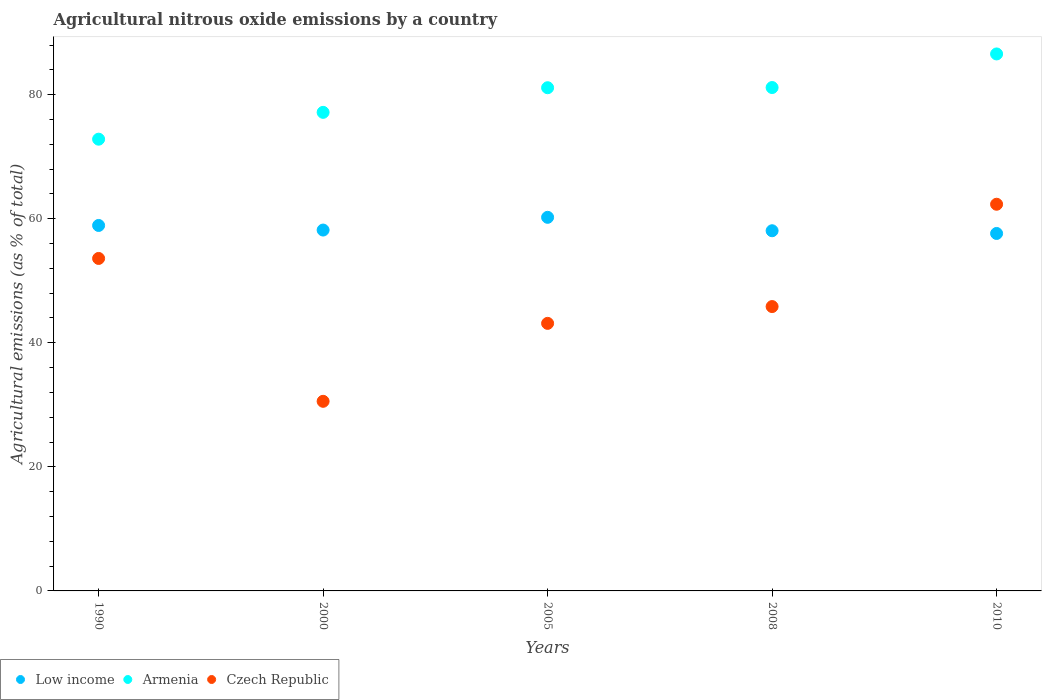Is the number of dotlines equal to the number of legend labels?
Provide a succinct answer. Yes. What is the amount of agricultural nitrous oxide emitted in Low income in 1990?
Provide a succinct answer. 58.91. Across all years, what is the maximum amount of agricultural nitrous oxide emitted in Armenia?
Offer a very short reply. 86.56. Across all years, what is the minimum amount of agricultural nitrous oxide emitted in Low income?
Offer a very short reply. 57.62. In which year was the amount of agricultural nitrous oxide emitted in Czech Republic maximum?
Offer a very short reply. 2010. What is the total amount of agricultural nitrous oxide emitted in Armenia in the graph?
Provide a succinct answer. 398.78. What is the difference between the amount of agricultural nitrous oxide emitted in Armenia in 2005 and that in 2010?
Keep it short and to the point. -5.45. What is the difference between the amount of agricultural nitrous oxide emitted in Armenia in 1990 and the amount of agricultural nitrous oxide emitted in Czech Republic in 2010?
Your answer should be very brief. 10.49. What is the average amount of agricultural nitrous oxide emitted in Armenia per year?
Offer a terse response. 79.76. In the year 1990, what is the difference between the amount of agricultural nitrous oxide emitted in Armenia and amount of agricultural nitrous oxide emitted in Low income?
Offer a terse response. 13.91. What is the ratio of the amount of agricultural nitrous oxide emitted in Low income in 2005 to that in 2010?
Provide a succinct answer. 1.05. Is the amount of agricultural nitrous oxide emitted in Armenia in 2000 less than that in 2005?
Keep it short and to the point. Yes. What is the difference between the highest and the second highest amount of agricultural nitrous oxide emitted in Armenia?
Give a very brief answer. 5.41. What is the difference between the highest and the lowest amount of agricultural nitrous oxide emitted in Czech Republic?
Ensure brevity in your answer.  31.77. Does the amount of agricultural nitrous oxide emitted in Armenia monotonically increase over the years?
Offer a terse response. Yes. Is the amount of agricultural nitrous oxide emitted in Armenia strictly greater than the amount of agricultural nitrous oxide emitted in Low income over the years?
Ensure brevity in your answer.  Yes. Is the amount of agricultural nitrous oxide emitted in Low income strictly less than the amount of agricultural nitrous oxide emitted in Armenia over the years?
Keep it short and to the point. Yes. Are the values on the major ticks of Y-axis written in scientific E-notation?
Make the answer very short. No. How many legend labels are there?
Provide a short and direct response. 3. What is the title of the graph?
Your answer should be very brief. Agricultural nitrous oxide emissions by a country. Does "West Bank and Gaza" appear as one of the legend labels in the graph?
Provide a succinct answer. No. What is the label or title of the Y-axis?
Ensure brevity in your answer.  Agricultural emissions (as % of total). What is the Agricultural emissions (as % of total) of Low income in 1990?
Your answer should be very brief. 58.91. What is the Agricultural emissions (as % of total) of Armenia in 1990?
Your answer should be compact. 72.82. What is the Agricultural emissions (as % of total) in Czech Republic in 1990?
Your answer should be compact. 53.6. What is the Agricultural emissions (as % of total) of Low income in 2000?
Provide a succinct answer. 58.17. What is the Agricultural emissions (as % of total) in Armenia in 2000?
Offer a terse response. 77.14. What is the Agricultural emissions (as % of total) in Czech Republic in 2000?
Give a very brief answer. 30.56. What is the Agricultural emissions (as % of total) of Low income in 2005?
Your answer should be compact. 60.22. What is the Agricultural emissions (as % of total) of Armenia in 2005?
Ensure brevity in your answer.  81.11. What is the Agricultural emissions (as % of total) in Czech Republic in 2005?
Offer a very short reply. 43.13. What is the Agricultural emissions (as % of total) in Low income in 2008?
Offer a terse response. 58.06. What is the Agricultural emissions (as % of total) in Armenia in 2008?
Make the answer very short. 81.15. What is the Agricultural emissions (as % of total) in Czech Republic in 2008?
Provide a succinct answer. 45.84. What is the Agricultural emissions (as % of total) in Low income in 2010?
Offer a very short reply. 57.62. What is the Agricultural emissions (as % of total) in Armenia in 2010?
Provide a succinct answer. 86.56. What is the Agricultural emissions (as % of total) of Czech Republic in 2010?
Provide a succinct answer. 62.33. Across all years, what is the maximum Agricultural emissions (as % of total) of Low income?
Provide a short and direct response. 60.22. Across all years, what is the maximum Agricultural emissions (as % of total) in Armenia?
Your answer should be very brief. 86.56. Across all years, what is the maximum Agricultural emissions (as % of total) of Czech Republic?
Keep it short and to the point. 62.33. Across all years, what is the minimum Agricultural emissions (as % of total) of Low income?
Offer a terse response. 57.62. Across all years, what is the minimum Agricultural emissions (as % of total) in Armenia?
Give a very brief answer. 72.82. Across all years, what is the minimum Agricultural emissions (as % of total) in Czech Republic?
Ensure brevity in your answer.  30.56. What is the total Agricultural emissions (as % of total) of Low income in the graph?
Make the answer very short. 292.99. What is the total Agricultural emissions (as % of total) in Armenia in the graph?
Your answer should be compact. 398.78. What is the total Agricultural emissions (as % of total) in Czech Republic in the graph?
Provide a short and direct response. 235.46. What is the difference between the Agricultural emissions (as % of total) of Low income in 1990 and that in 2000?
Offer a very short reply. 0.74. What is the difference between the Agricultural emissions (as % of total) of Armenia in 1990 and that in 2000?
Ensure brevity in your answer.  -4.32. What is the difference between the Agricultural emissions (as % of total) of Czech Republic in 1990 and that in 2000?
Provide a short and direct response. 23.03. What is the difference between the Agricultural emissions (as % of total) in Low income in 1990 and that in 2005?
Keep it short and to the point. -1.31. What is the difference between the Agricultural emissions (as % of total) of Armenia in 1990 and that in 2005?
Your answer should be compact. -8.29. What is the difference between the Agricultural emissions (as % of total) of Czech Republic in 1990 and that in 2005?
Keep it short and to the point. 10.47. What is the difference between the Agricultural emissions (as % of total) in Low income in 1990 and that in 2008?
Make the answer very short. 0.85. What is the difference between the Agricultural emissions (as % of total) in Armenia in 1990 and that in 2008?
Keep it short and to the point. -8.33. What is the difference between the Agricultural emissions (as % of total) in Czech Republic in 1990 and that in 2008?
Ensure brevity in your answer.  7.76. What is the difference between the Agricultural emissions (as % of total) of Low income in 1990 and that in 2010?
Make the answer very short. 1.29. What is the difference between the Agricultural emissions (as % of total) in Armenia in 1990 and that in 2010?
Ensure brevity in your answer.  -13.74. What is the difference between the Agricultural emissions (as % of total) of Czech Republic in 1990 and that in 2010?
Offer a terse response. -8.74. What is the difference between the Agricultural emissions (as % of total) of Low income in 2000 and that in 2005?
Your answer should be compact. -2.05. What is the difference between the Agricultural emissions (as % of total) in Armenia in 2000 and that in 2005?
Your answer should be very brief. -3.97. What is the difference between the Agricultural emissions (as % of total) in Czech Republic in 2000 and that in 2005?
Offer a very short reply. -12.57. What is the difference between the Agricultural emissions (as % of total) of Low income in 2000 and that in 2008?
Make the answer very short. 0.11. What is the difference between the Agricultural emissions (as % of total) in Armenia in 2000 and that in 2008?
Your answer should be very brief. -4. What is the difference between the Agricultural emissions (as % of total) in Czech Republic in 2000 and that in 2008?
Your answer should be compact. -15.27. What is the difference between the Agricultural emissions (as % of total) in Low income in 2000 and that in 2010?
Make the answer very short. 0.55. What is the difference between the Agricultural emissions (as % of total) in Armenia in 2000 and that in 2010?
Your answer should be very brief. -9.42. What is the difference between the Agricultural emissions (as % of total) of Czech Republic in 2000 and that in 2010?
Give a very brief answer. -31.77. What is the difference between the Agricultural emissions (as % of total) in Low income in 2005 and that in 2008?
Give a very brief answer. 2.16. What is the difference between the Agricultural emissions (as % of total) in Armenia in 2005 and that in 2008?
Ensure brevity in your answer.  -0.03. What is the difference between the Agricultural emissions (as % of total) in Czech Republic in 2005 and that in 2008?
Your response must be concise. -2.71. What is the difference between the Agricultural emissions (as % of total) of Low income in 2005 and that in 2010?
Keep it short and to the point. 2.6. What is the difference between the Agricultural emissions (as % of total) in Armenia in 2005 and that in 2010?
Ensure brevity in your answer.  -5.45. What is the difference between the Agricultural emissions (as % of total) of Czech Republic in 2005 and that in 2010?
Give a very brief answer. -19.2. What is the difference between the Agricultural emissions (as % of total) in Low income in 2008 and that in 2010?
Keep it short and to the point. 0.44. What is the difference between the Agricultural emissions (as % of total) of Armenia in 2008 and that in 2010?
Offer a very short reply. -5.41. What is the difference between the Agricultural emissions (as % of total) of Czech Republic in 2008 and that in 2010?
Keep it short and to the point. -16.49. What is the difference between the Agricultural emissions (as % of total) in Low income in 1990 and the Agricultural emissions (as % of total) in Armenia in 2000?
Give a very brief answer. -18.23. What is the difference between the Agricultural emissions (as % of total) of Low income in 1990 and the Agricultural emissions (as % of total) of Czech Republic in 2000?
Keep it short and to the point. 28.35. What is the difference between the Agricultural emissions (as % of total) in Armenia in 1990 and the Agricultural emissions (as % of total) in Czech Republic in 2000?
Ensure brevity in your answer.  42.26. What is the difference between the Agricultural emissions (as % of total) of Low income in 1990 and the Agricultural emissions (as % of total) of Armenia in 2005?
Your answer should be very brief. -22.2. What is the difference between the Agricultural emissions (as % of total) in Low income in 1990 and the Agricultural emissions (as % of total) in Czech Republic in 2005?
Offer a terse response. 15.78. What is the difference between the Agricultural emissions (as % of total) in Armenia in 1990 and the Agricultural emissions (as % of total) in Czech Republic in 2005?
Ensure brevity in your answer.  29.69. What is the difference between the Agricultural emissions (as % of total) in Low income in 1990 and the Agricultural emissions (as % of total) in Armenia in 2008?
Give a very brief answer. -22.23. What is the difference between the Agricultural emissions (as % of total) in Low income in 1990 and the Agricultural emissions (as % of total) in Czech Republic in 2008?
Your response must be concise. 13.07. What is the difference between the Agricultural emissions (as % of total) in Armenia in 1990 and the Agricultural emissions (as % of total) in Czech Republic in 2008?
Your answer should be very brief. 26.98. What is the difference between the Agricultural emissions (as % of total) in Low income in 1990 and the Agricultural emissions (as % of total) in Armenia in 2010?
Keep it short and to the point. -27.65. What is the difference between the Agricultural emissions (as % of total) of Low income in 1990 and the Agricultural emissions (as % of total) of Czech Republic in 2010?
Give a very brief answer. -3.42. What is the difference between the Agricultural emissions (as % of total) of Armenia in 1990 and the Agricultural emissions (as % of total) of Czech Republic in 2010?
Provide a short and direct response. 10.49. What is the difference between the Agricultural emissions (as % of total) of Low income in 2000 and the Agricultural emissions (as % of total) of Armenia in 2005?
Your answer should be very brief. -22.94. What is the difference between the Agricultural emissions (as % of total) in Low income in 2000 and the Agricultural emissions (as % of total) in Czech Republic in 2005?
Your answer should be compact. 15.04. What is the difference between the Agricultural emissions (as % of total) of Armenia in 2000 and the Agricultural emissions (as % of total) of Czech Republic in 2005?
Give a very brief answer. 34.01. What is the difference between the Agricultural emissions (as % of total) of Low income in 2000 and the Agricultural emissions (as % of total) of Armenia in 2008?
Provide a succinct answer. -22.97. What is the difference between the Agricultural emissions (as % of total) of Low income in 2000 and the Agricultural emissions (as % of total) of Czech Republic in 2008?
Give a very brief answer. 12.33. What is the difference between the Agricultural emissions (as % of total) of Armenia in 2000 and the Agricultural emissions (as % of total) of Czech Republic in 2008?
Keep it short and to the point. 31.31. What is the difference between the Agricultural emissions (as % of total) of Low income in 2000 and the Agricultural emissions (as % of total) of Armenia in 2010?
Your answer should be compact. -28.39. What is the difference between the Agricultural emissions (as % of total) of Low income in 2000 and the Agricultural emissions (as % of total) of Czech Republic in 2010?
Keep it short and to the point. -4.16. What is the difference between the Agricultural emissions (as % of total) of Armenia in 2000 and the Agricultural emissions (as % of total) of Czech Republic in 2010?
Offer a very short reply. 14.81. What is the difference between the Agricultural emissions (as % of total) in Low income in 2005 and the Agricultural emissions (as % of total) in Armenia in 2008?
Offer a terse response. -20.92. What is the difference between the Agricultural emissions (as % of total) of Low income in 2005 and the Agricultural emissions (as % of total) of Czech Republic in 2008?
Offer a terse response. 14.39. What is the difference between the Agricultural emissions (as % of total) in Armenia in 2005 and the Agricultural emissions (as % of total) in Czech Republic in 2008?
Keep it short and to the point. 35.28. What is the difference between the Agricultural emissions (as % of total) of Low income in 2005 and the Agricultural emissions (as % of total) of Armenia in 2010?
Ensure brevity in your answer.  -26.34. What is the difference between the Agricultural emissions (as % of total) in Low income in 2005 and the Agricultural emissions (as % of total) in Czech Republic in 2010?
Your answer should be very brief. -2.11. What is the difference between the Agricultural emissions (as % of total) in Armenia in 2005 and the Agricultural emissions (as % of total) in Czech Republic in 2010?
Give a very brief answer. 18.78. What is the difference between the Agricultural emissions (as % of total) in Low income in 2008 and the Agricultural emissions (as % of total) in Armenia in 2010?
Your answer should be compact. -28.5. What is the difference between the Agricultural emissions (as % of total) of Low income in 2008 and the Agricultural emissions (as % of total) of Czech Republic in 2010?
Your response must be concise. -4.27. What is the difference between the Agricultural emissions (as % of total) in Armenia in 2008 and the Agricultural emissions (as % of total) in Czech Republic in 2010?
Make the answer very short. 18.81. What is the average Agricultural emissions (as % of total) of Low income per year?
Your answer should be compact. 58.6. What is the average Agricultural emissions (as % of total) in Armenia per year?
Your answer should be compact. 79.76. What is the average Agricultural emissions (as % of total) in Czech Republic per year?
Provide a short and direct response. 47.09. In the year 1990, what is the difference between the Agricultural emissions (as % of total) in Low income and Agricultural emissions (as % of total) in Armenia?
Your answer should be very brief. -13.91. In the year 1990, what is the difference between the Agricultural emissions (as % of total) of Low income and Agricultural emissions (as % of total) of Czech Republic?
Make the answer very short. 5.32. In the year 1990, what is the difference between the Agricultural emissions (as % of total) in Armenia and Agricultural emissions (as % of total) in Czech Republic?
Your response must be concise. 19.22. In the year 2000, what is the difference between the Agricultural emissions (as % of total) in Low income and Agricultural emissions (as % of total) in Armenia?
Provide a short and direct response. -18.97. In the year 2000, what is the difference between the Agricultural emissions (as % of total) of Low income and Agricultural emissions (as % of total) of Czech Republic?
Give a very brief answer. 27.61. In the year 2000, what is the difference between the Agricultural emissions (as % of total) in Armenia and Agricultural emissions (as % of total) in Czech Republic?
Keep it short and to the point. 46.58. In the year 2005, what is the difference between the Agricultural emissions (as % of total) in Low income and Agricultural emissions (as % of total) in Armenia?
Offer a terse response. -20.89. In the year 2005, what is the difference between the Agricultural emissions (as % of total) of Low income and Agricultural emissions (as % of total) of Czech Republic?
Your answer should be compact. 17.09. In the year 2005, what is the difference between the Agricultural emissions (as % of total) of Armenia and Agricultural emissions (as % of total) of Czech Republic?
Provide a short and direct response. 37.98. In the year 2008, what is the difference between the Agricultural emissions (as % of total) of Low income and Agricultural emissions (as % of total) of Armenia?
Make the answer very short. -23.09. In the year 2008, what is the difference between the Agricultural emissions (as % of total) of Low income and Agricultural emissions (as % of total) of Czech Republic?
Your answer should be very brief. 12.22. In the year 2008, what is the difference between the Agricultural emissions (as % of total) of Armenia and Agricultural emissions (as % of total) of Czech Republic?
Your answer should be compact. 35.31. In the year 2010, what is the difference between the Agricultural emissions (as % of total) in Low income and Agricultural emissions (as % of total) in Armenia?
Provide a short and direct response. -28.94. In the year 2010, what is the difference between the Agricultural emissions (as % of total) in Low income and Agricultural emissions (as % of total) in Czech Republic?
Offer a terse response. -4.71. In the year 2010, what is the difference between the Agricultural emissions (as % of total) of Armenia and Agricultural emissions (as % of total) of Czech Republic?
Your answer should be very brief. 24.23. What is the ratio of the Agricultural emissions (as % of total) of Low income in 1990 to that in 2000?
Offer a terse response. 1.01. What is the ratio of the Agricultural emissions (as % of total) in Armenia in 1990 to that in 2000?
Your response must be concise. 0.94. What is the ratio of the Agricultural emissions (as % of total) in Czech Republic in 1990 to that in 2000?
Your response must be concise. 1.75. What is the ratio of the Agricultural emissions (as % of total) in Low income in 1990 to that in 2005?
Make the answer very short. 0.98. What is the ratio of the Agricultural emissions (as % of total) in Armenia in 1990 to that in 2005?
Your answer should be compact. 0.9. What is the ratio of the Agricultural emissions (as % of total) of Czech Republic in 1990 to that in 2005?
Provide a succinct answer. 1.24. What is the ratio of the Agricultural emissions (as % of total) of Low income in 1990 to that in 2008?
Your answer should be very brief. 1.01. What is the ratio of the Agricultural emissions (as % of total) of Armenia in 1990 to that in 2008?
Offer a very short reply. 0.9. What is the ratio of the Agricultural emissions (as % of total) in Czech Republic in 1990 to that in 2008?
Ensure brevity in your answer.  1.17. What is the ratio of the Agricultural emissions (as % of total) in Low income in 1990 to that in 2010?
Your answer should be compact. 1.02. What is the ratio of the Agricultural emissions (as % of total) in Armenia in 1990 to that in 2010?
Offer a terse response. 0.84. What is the ratio of the Agricultural emissions (as % of total) of Czech Republic in 1990 to that in 2010?
Provide a short and direct response. 0.86. What is the ratio of the Agricultural emissions (as % of total) in Low income in 2000 to that in 2005?
Offer a very short reply. 0.97. What is the ratio of the Agricultural emissions (as % of total) in Armenia in 2000 to that in 2005?
Provide a succinct answer. 0.95. What is the ratio of the Agricultural emissions (as % of total) in Czech Republic in 2000 to that in 2005?
Provide a short and direct response. 0.71. What is the ratio of the Agricultural emissions (as % of total) in Low income in 2000 to that in 2008?
Give a very brief answer. 1. What is the ratio of the Agricultural emissions (as % of total) in Armenia in 2000 to that in 2008?
Provide a short and direct response. 0.95. What is the ratio of the Agricultural emissions (as % of total) in Czech Republic in 2000 to that in 2008?
Make the answer very short. 0.67. What is the ratio of the Agricultural emissions (as % of total) in Low income in 2000 to that in 2010?
Keep it short and to the point. 1.01. What is the ratio of the Agricultural emissions (as % of total) in Armenia in 2000 to that in 2010?
Your answer should be very brief. 0.89. What is the ratio of the Agricultural emissions (as % of total) of Czech Republic in 2000 to that in 2010?
Make the answer very short. 0.49. What is the ratio of the Agricultural emissions (as % of total) of Low income in 2005 to that in 2008?
Offer a terse response. 1.04. What is the ratio of the Agricultural emissions (as % of total) in Armenia in 2005 to that in 2008?
Provide a succinct answer. 1. What is the ratio of the Agricultural emissions (as % of total) of Czech Republic in 2005 to that in 2008?
Your response must be concise. 0.94. What is the ratio of the Agricultural emissions (as % of total) of Low income in 2005 to that in 2010?
Make the answer very short. 1.05. What is the ratio of the Agricultural emissions (as % of total) of Armenia in 2005 to that in 2010?
Make the answer very short. 0.94. What is the ratio of the Agricultural emissions (as % of total) of Czech Republic in 2005 to that in 2010?
Your answer should be compact. 0.69. What is the ratio of the Agricultural emissions (as % of total) in Low income in 2008 to that in 2010?
Offer a very short reply. 1.01. What is the ratio of the Agricultural emissions (as % of total) in Armenia in 2008 to that in 2010?
Your answer should be compact. 0.94. What is the ratio of the Agricultural emissions (as % of total) of Czech Republic in 2008 to that in 2010?
Your answer should be very brief. 0.74. What is the difference between the highest and the second highest Agricultural emissions (as % of total) in Low income?
Ensure brevity in your answer.  1.31. What is the difference between the highest and the second highest Agricultural emissions (as % of total) of Armenia?
Provide a succinct answer. 5.41. What is the difference between the highest and the second highest Agricultural emissions (as % of total) in Czech Republic?
Provide a short and direct response. 8.74. What is the difference between the highest and the lowest Agricultural emissions (as % of total) in Low income?
Your response must be concise. 2.6. What is the difference between the highest and the lowest Agricultural emissions (as % of total) of Armenia?
Your response must be concise. 13.74. What is the difference between the highest and the lowest Agricultural emissions (as % of total) in Czech Republic?
Keep it short and to the point. 31.77. 